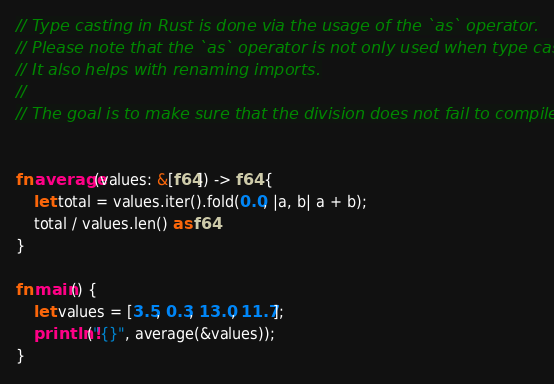<code> <loc_0><loc_0><loc_500><loc_500><_Rust_>// Type casting in Rust is done via the usage of the `as` operator.
// Please note that the `as` operator is not only used when type casting.
// It also helps with renaming imports.
//
// The goal is to make sure that the division does not fail to compile


fn average(values: &[f64]) -> f64 {
    let total = values.iter().fold(0.0, |a, b| a + b);
    total / values.len() as f64
}

fn main() {
    let values = [3.5, 0.3, 13.0, 11.7];
    println!("{}", average(&values));
}
</code> 